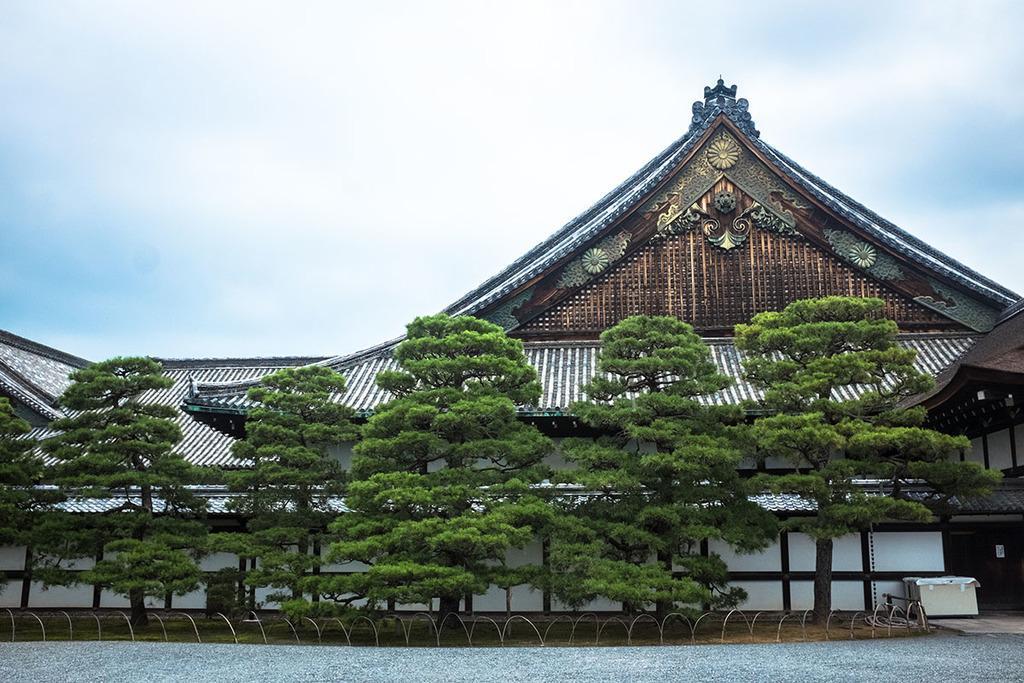Please provide a concise description of this image. This picture is clicked outside. In the foreground we can see the metal rods, a box and trees and we can see the house. In the background there is a sky. 